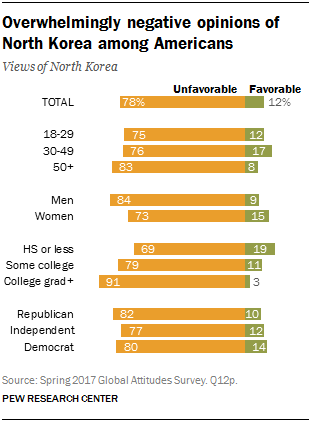Mention a couple of crucial points in this snapshot. The value of the lowest green bar is 3. The difference between the highest green value and the lowest yellow value is 50. 